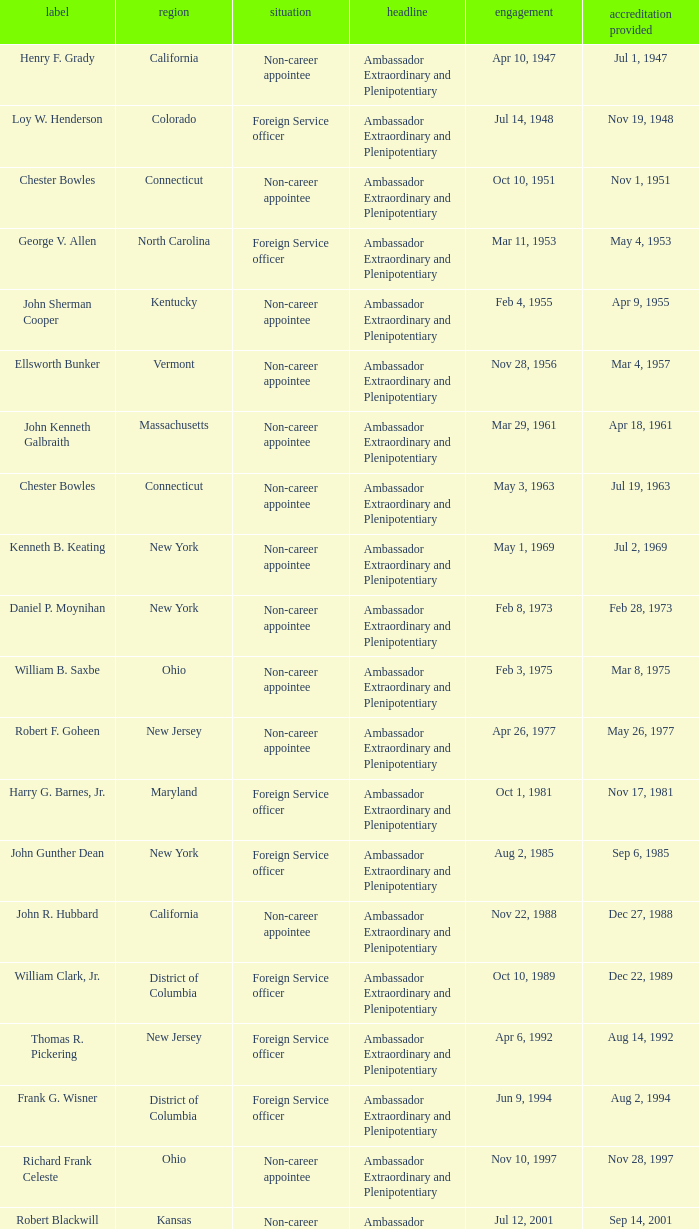What day were credentials presented for vermont? Mar 4, 1957. 